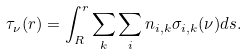<formula> <loc_0><loc_0><loc_500><loc_500>\tau _ { \nu } ( r ) = \int _ { R } ^ { r } \sum _ { k } \sum _ { i } n _ { i , k } \sigma _ { i , k } ( \nu ) d s .</formula> 